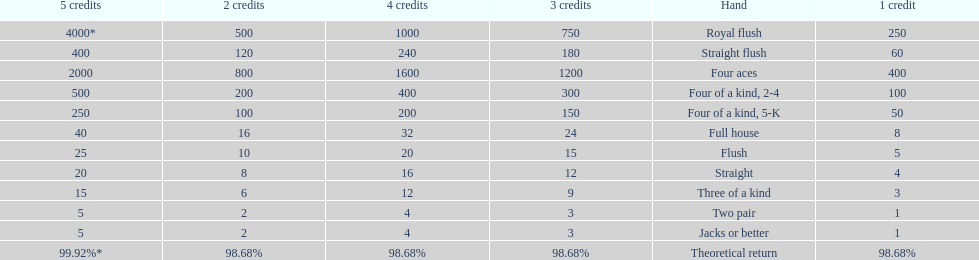How many straight wins at 3 credits equals one straight flush win at two credits? 10. 